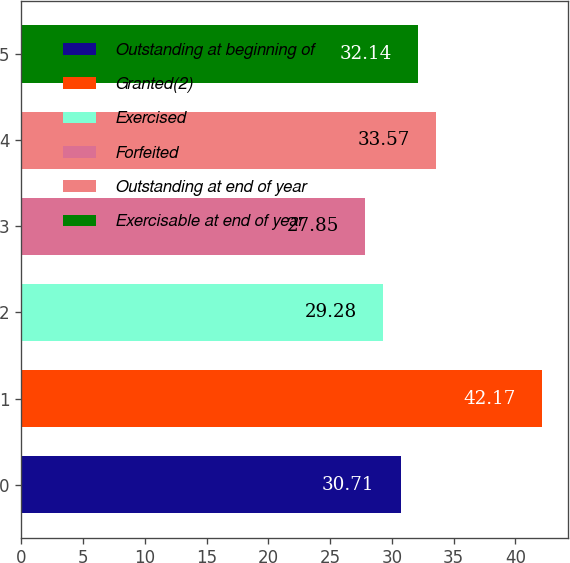<chart> <loc_0><loc_0><loc_500><loc_500><bar_chart><fcel>Outstanding at beginning of<fcel>Granted(2)<fcel>Exercised<fcel>Forfeited<fcel>Outstanding at end of year<fcel>Exercisable at end of year<nl><fcel>30.71<fcel>42.17<fcel>29.28<fcel>27.85<fcel>33.57<fcel>32.14<nl></chart> 